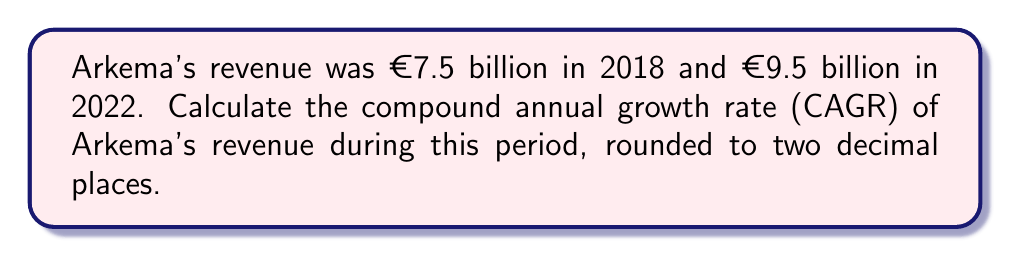Could you help me with this problem? To calculate the Compound Annual Growth Rate (CAGR), we use the formula:

$$ CAGR = \left(\frac{Ending Value}{Beginning Value}\right)^{\frac{1}{n}} - 1 $$

Where:
- Ending Value = €9.5 billion
- Beginning Value = €7.5 billion
- n = number of years = 2022 - 2018 = 4 years

Step 1: Plug the values into the formula
$$ CAGR = \left(\frac{9.5}{7.5}\right)^{\frac{1}{4}} - 1 $$

Step 2: Calculate the fraction inside the parentheses
$$ CAGR = (1.2667)^{\frac{1}{4}} - 1 $$

Step 3: Calculate the fourth root
$$ CAGR = 1.0610 - 1 $$

Step 4: Subtract 1 and convert to a percentage
$$ CAGR = 0.0610 = 6.10\% $$

Therefore, the CAGR of Arkema's revenue from 2018 to 2022 is 6.10%.
Answer: 6.10% 